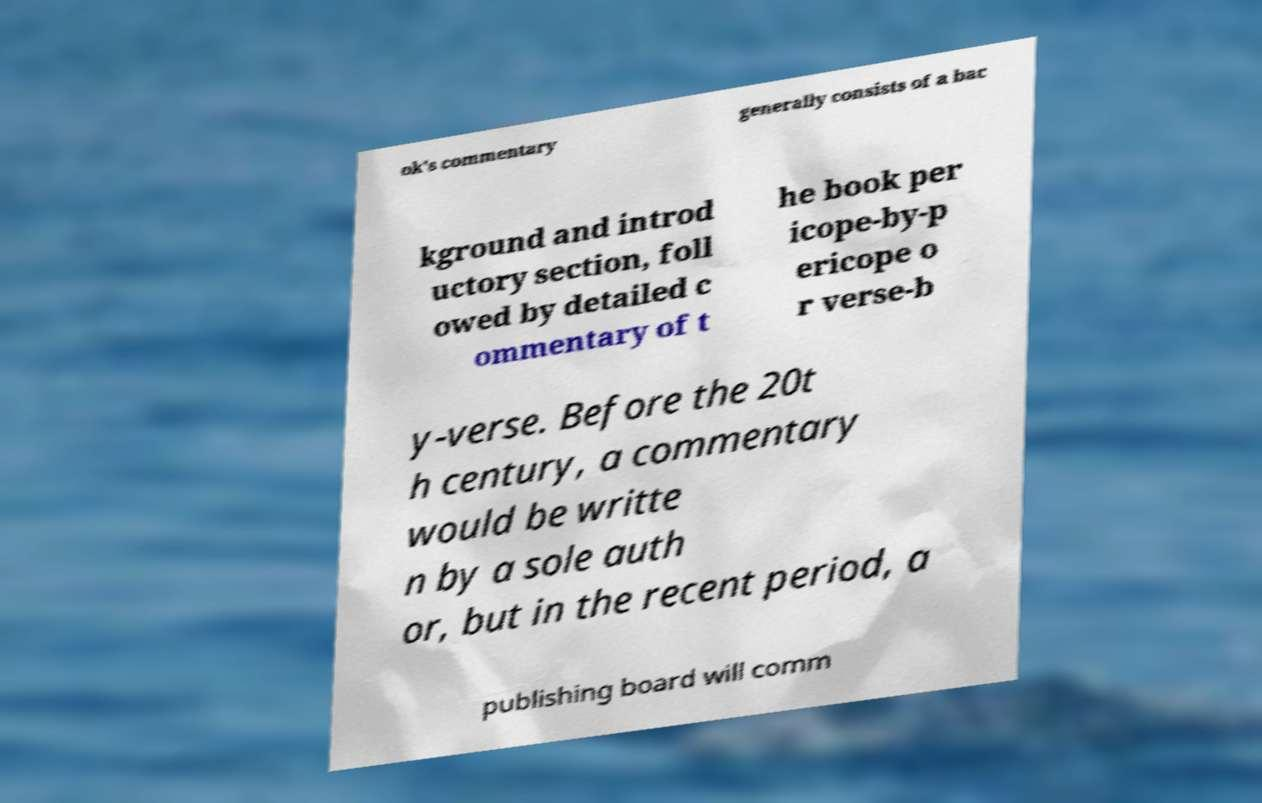Please read and relay the text visible in this image. What does it say? ok's commentary generally consists of a bac kground and introd uctory section, foll owed by detailed c ommentary of t he book per icope-by-p ericope o r verse-b y-verse. Before the 20t h century, a commentary would be writte n by a sole auth or, but in the recent period, a publishing board will comm 